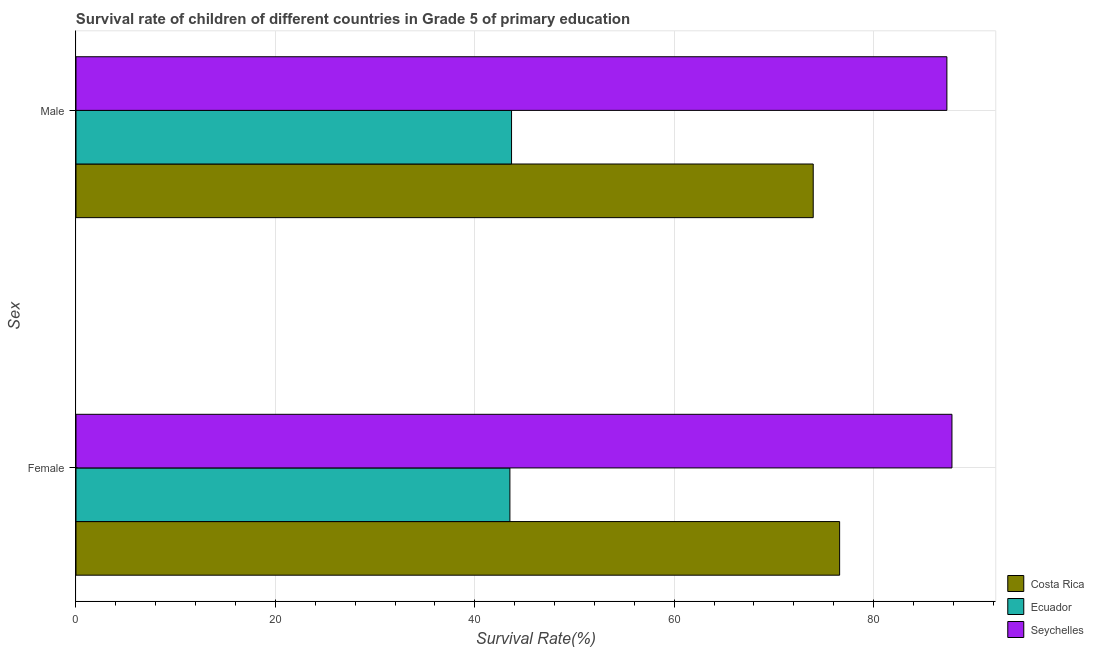How many different coloured bars are there?
Give a very brief answer. 3. How many groups of bars are there?
Your answer should be very brief. 2. Are the number of bars on each tick of the Y-axis equal?
Provide a short and direct response. Yes. What is the label of the 2nd group of bars from the top?
Offer a terse response. Female. What is the survival rate of male students in primary education in Costa Rica?
Make the answer very short. 73.95. Across all countries, what is the maximum survival rate of female students in primary education?
Give a very brief answer. 87.87. Across all countries, what is the minimum survival rate of female students in primary education?
Provide a short and direct response. 43.53. In which country was the survival rate of male students in primary education maximum?
Your answer should be very brief. Seychelles. In which country was the survival rate of male students in primary education minimum?
Give a very brief answer. Ecuador. What is the total survival rate of female students in primary education in the graph?
Your answer should be compact. 207.99. What is the difference between the survival rate of female students in primary education in Costa Rica and that in Seychelles?
Your answer should be very brief. -11.27. What is the difference between the survival rate of male students in primary education in Costa Rica and the survival rate of female students in primary education in Ecuador?
Your response must be concise. 30.43. What is the average survival rate of male students in primary education per country?
Make the answer very short. 68.33. What is the difference between the survival rate of male students in primary education and survival rate of female students in primary education in Costa Rica?
Provide a short and direct response. -2.65. What is the ratio of the survival rate of female students in primary education in Ecuador to that in Costa Rica?
Your answer should be very brief. 0.57. What does the 3rd bar from the bottom in Female represents?
Your answer should be compact. Seychelles. How many bars are there?
Your answer should be compact. 6. How many countries are there in the graph?
Keep it short and to the point. 3. Are the values on the major ticks of X-axis written in scientific E-notation?
Your response must be concise. No. Does the graph contain any zero values?
Your answer should be compact. No. Where does the legend appear in the graph?
Keep it short and to the point. Bottom right. How many legend labels are there?
Your response must be concise. 3. How are the legend labels stacked?
Ensure brevity in your answer.  Vertical. What is the title of the graph?
Provide a short and direct response. Survival rate of children of different countries in Grade 5 of primary education. What is the label or title of the X-axis?
Keep it short and to the point. Survival Rate(%). What is the label or title of the Y-axis?
Keep it short and to the point. Sex. What is the Survival Rate(%) in Costa Rica in Female?
Keep it short and to the point. 76.6. What is the Survival Rate(%) in Ecuador in Female?
Your answer should be very brief. 43.53. What is the Survival Rate(%) in Seychelles in Female?
Your answer should be compact. 87.87. What is the Survival Rate(%) in Costa Rica in Male?
Keep it short and to the point. 73.95. What is the Survival Rate(%) of Ecuador in Male?
Your response must be concise. 43.69. What is the Survival Rate(%) in Seychelles in Male?
Offer a very short reply. 87.36. Across all Sex, what is the maximum Survival Rate(%) of Costa Rica?
Keep it short and to the point. 76.6. Across all Sex, what is the maximum Survival Rate(%) of Ecuador?
Keep it short and to the point. 43.69. Across all Sex, what is the maximum Survival Rate(%) of Seychelles?
Keep it short and to the point. 87.87. Across all Sex, what is the minimum Survival Rate(%) of Costa Rica?
Offer a very short reply. 73.95. Across all Sex, what is the minimum Survival Rate(%) in Ecuador?
Ensure brevity in your answer.  43.53. Across all Sex, what is the minimum Survival Rate(%) of Seychelles?
Give a very brief answer. 87.36. What is the total Survival Rate(%) in Costa Rica in the graph?
Give a very brief answer. 150.55. What is the total Survival Rate(%) in Ecuador in the graph?
Ensure brevity in your answer.  87.22. What is the total Survival Rate(%) of Seychelles in the graph?
Your answer should be compact. 175.23. What is the difference between the Survival Rate(%) in Costa Rica in Female and that in Male?
Provide a short and direct response. 2.65. What is the difference between the Survival Rate(%) of Ecuador in Female and that in Male?
Your answer should be very brief. -0.16. What is the difference between the Survival Rate(%) in Seychelles in Female and that in Male?
Offer a very short reply. 0.51. What is the difference between the Survival Rate(%) in Costa Rica in Female and the Survival Rate(%) in Ecuador in Male?
Your response must be concise. 32.91. What is the difference between the Survival Rate(%) of Costa Rica in Female and the Survival Rate(%) of Seychelles in Male?
Your answer should be very brief. -10.76. What is the difference between the Survival Rate(%) of Ecuador in Female and the Survival Rate(%) of Seychelles in Male?
Keep it short and to the point. -43.83. What is the average Survival Rate(%) in Costa Rica per Sex?
Keep it short and to the point. 75.28. What is the average Survival Rate(%) of Ecuador per Sex?
Keep it short and to the point. 43.61. What is the average Survival Rate(%) of Seychelles per Sex?
Your answer should be very brief. 87.61. What is the difference between the Survival Rate(%) in Costa Rica and Survival Rate(%) in Ecuador in Female?
Give a very brief answer. 33.07. What is the difference between the Survival Rate(%) of Costa Rica and Survival Rate(%) of Seychelles in Female?
Offer a very short reply. -11.27. What is the difference between the Survival Rate(%) of Ecuador and Survival Rate(%) of Seychelles in Female?
Keep it short and to the point. -44.34. What is the difference between the Survival Rate(%) in Costa Rica and Survival Rate(%) in Ecuador in Male?
Ensure brevity in your answer.  30.26. What is the difference between the Survival Rate(%) of Costa Rica and Survival Rate(%) of Seychelles in Male?
Make the answer very short. -13.41. What is the difference between the Survival Rate(%) in Ecuador and Survival Rate(%) in Seychelles in Male?
Provide a short and direct response. -43.67. What is the ratio of the Survival Rate(%) of Costa Rica in Female to that in Male?
Provide a short and direct response. 1.04. What is the difference between the highest and the second highest Survival Rate(%) in Costa Rica?
Make the answer very short. 2.65. What is the difference between the highest and the second highest Survival Rate(%) in Ecuador?
Give a very brief answer. 0.16. What is the difference between the highest and the second highest Survival Rate(%) in Seychelles?
Your answer should be compact. 0.51. What is the difference between the highest and the lowest Survival Rate(%) in Costa Rica?
Give a very brief answer. 2.65. What is the difference between the highest and the lowest Survival Rate(%) in Ecuador?
Provide a succinct answer. 0.16. What is the difference between the highest and the lowest Survival Rate(%) in Seychelles?
Keep it short and to the point. 0.51. 